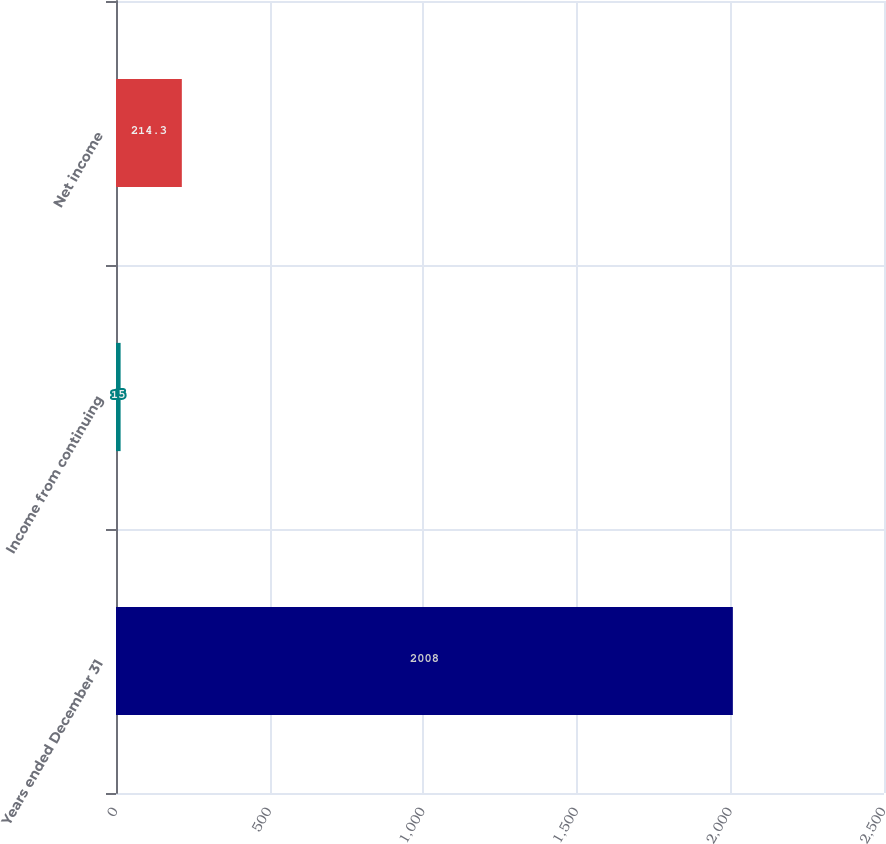Convert chart. <chart><loc_0><loc_0><loc_500><loc_500><bar_chart><fcel>Years ended December 31<fcel>Income from continuing<fcel>Net income<nl><fcel>2008<fcel>15<fcel>214.3<nl></chart> 